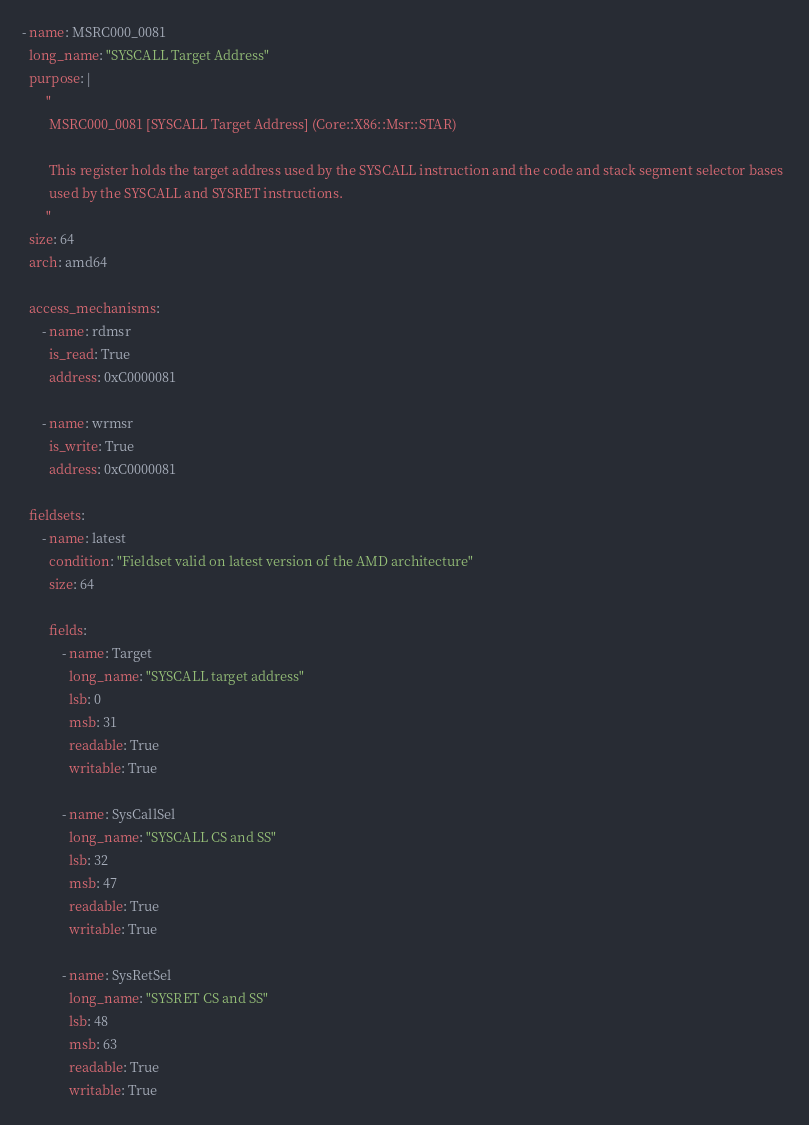<code> <loc_0><loc_0><loc_500><loc_500><_YAML_>- name: MSRC000_0081
  long_name: "SYSCALL Target Address"
  purpose: |
       "
        MSRC000_0081 [SYSCALL Target Address] (Core::X86::Msr::STAR)

        This register holds the target address used by the SYSCALL instruction and the code and stack segment selector bases 
        used by the SYSCALL and SYSRET instructions.
       "
  size: 64
  arch: amd64

  access_mechanisms:
      - name: rdmsr
        is_read: True
        address: 0xC0000081

      - name: wrmsr
        is_write: True
        address: 0xC0000081 

  fieldsets:
      - name: latest
        condition: "Fieldset valid on latest version of the AMD architecture"
        size: 64

        fields:
            - name: Target
              long_name: "SYSCALL target address"
              lsb: 0
              msb: 31
              readable: True 
              writable: True

            - name: SysCallSel
              long_name: "SYSCALL CS and SS"
              lsb: 32
              msb: 47
              readable: True 
              writable: True

            - name: SysRetSel
              long_name: "SYSRET CS and SS"
              lsb: 48
              msb: 63
              readable: True 
              writable: True
</code> 